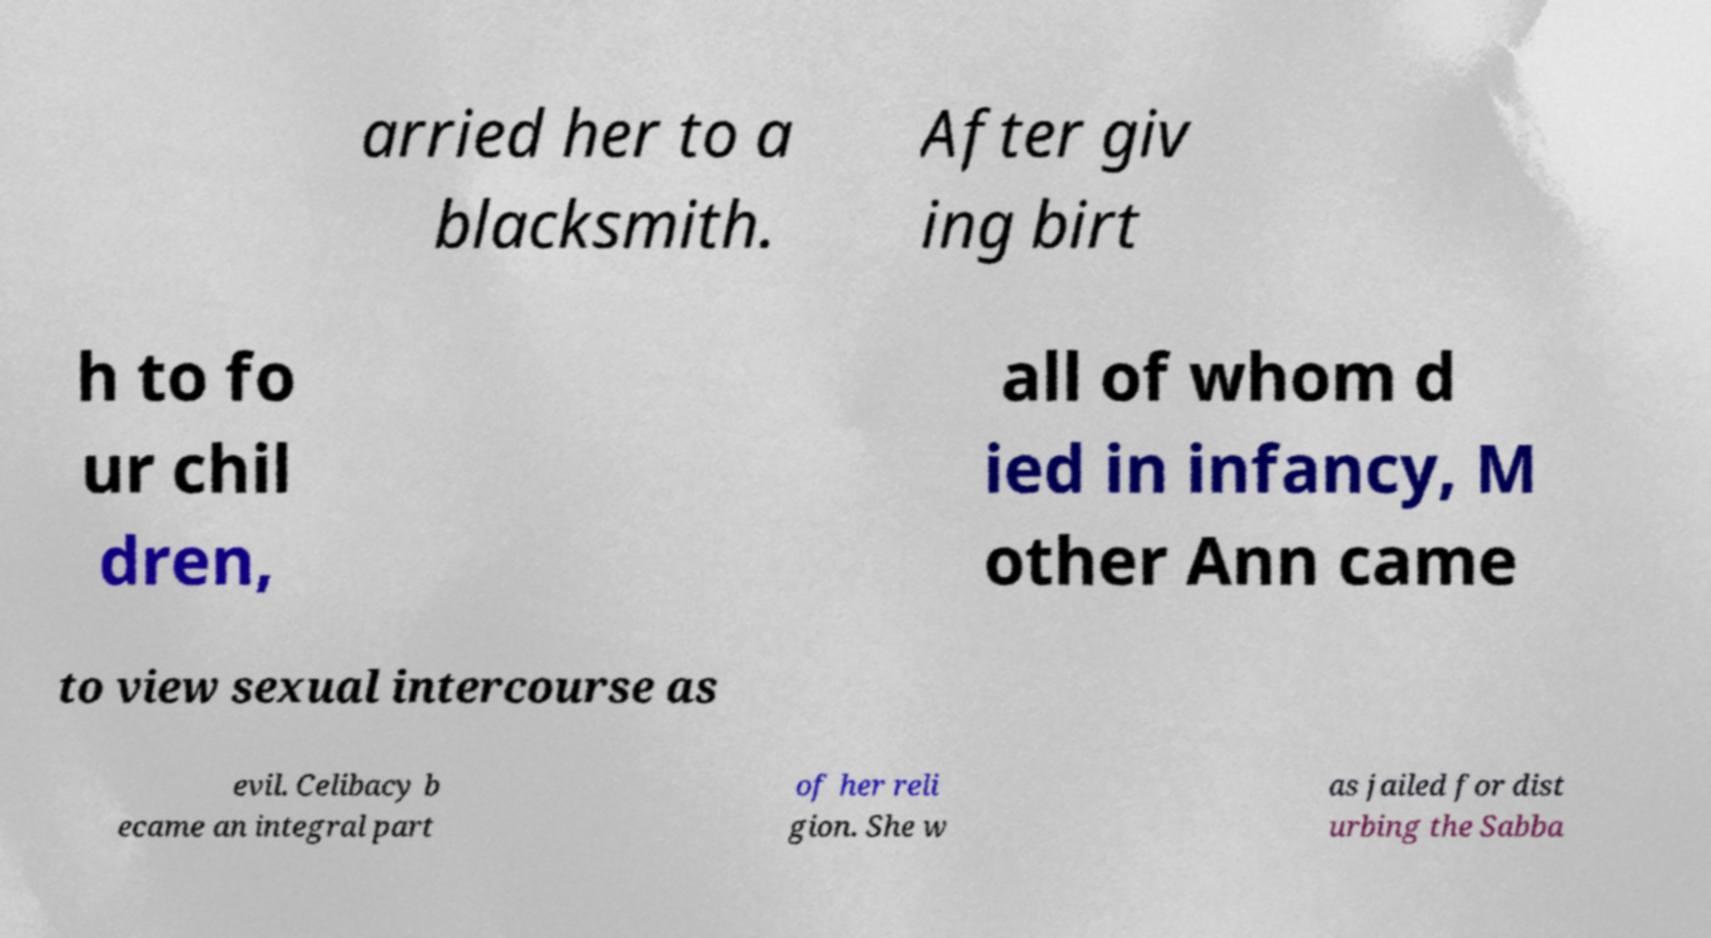What messages or text are displayed in this image? I need them in a readable, typed format. arried her to a blacksmith. After giv ing birt h to fo ur chil dren, all of whom d ied in infancy, M other Ann came to view sexual intercourse as evil. Celibacy b ecame an integral part of her reli gion. She w as jailed for dist urbing the Sabba 